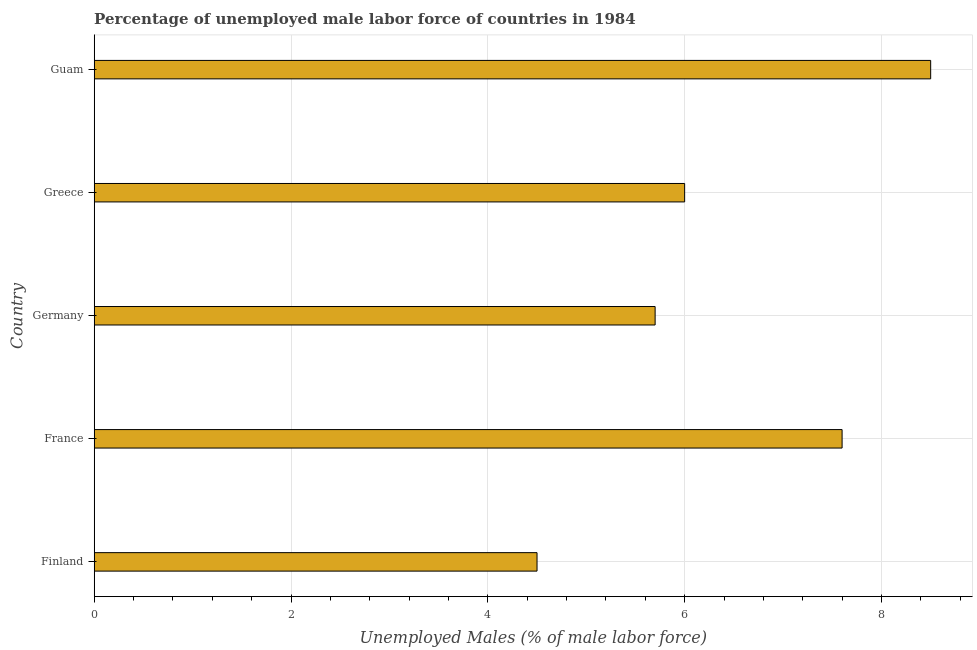Does the graph contain grids?
Ensure brevity in your answer.  Yes. What is the title of the graph?
Offer a very short reply. Percentage of unemployed male labor force of countries in 1984. What is the label or title of the X-axis?
Your answer should be very brief. Unemployed Males (% of male labor force). What is the total unemployed male labour force in Finland?
Your answer should be very brief. 4.5. Across all countries, what is the minimum total unemployed male labour force?
Your answer should be very brief. 4.5. In which country was the total unemployed male labour force maximum?
Ensure brevity in your answer.  Guam. In which country was the total unemployed male labour force minimum?
Give a very brief answer. Finland. What is the sum of the total unemployed male labour force?
Give a very brief answer. 32.3. What is the difference between the total unemployed male labour force in Finland and Greece?
Offer a very short reply. -1.5. What is the average total unemployed male labour force per country?
Keep it short and to the point. 6.46. What is the median total unemployed male labour force?
Make the answer very short. 6. In how many countries, is the total unemployed male labour force greater than 8 %?
Ensure brevity in your answer.  1. What is the ratio of the total unemployed male labour force in Finland to that in Greece?
Provide a short and direct response. 0.75. What is the difference between the highest and the second highest total unemployed male labour force?
Offer a terse response. 0.9. In how many countries, is the total unemployed male labour force greater than the average total unemployed male labour force taken over all countries?
Give a very brief answer. 2. How many bars are there?
Provide a short and direct response. 5. How many countries are there in the graph?
Give a very brief answer. 5. What is the Unemployed Males (% of male labor force) in Finland?
Offer a very short reply. 4.5. What is the Unemployed Males (% of male labor force) of France?
Provide a succinct answer. 7.6. What is the Unemployed Males (% of male labor force) in Germany?
Offer a very short reply. 5.7. What is the Unemployed Males (% of male labor force) of Greece?
Give a very brief answer. 6. What is the difference between the Unemployed Males (% of male labor force) in Finland and Germany?
Provide a succinct answer. -1.2. What is the difference between the Unemployed Males (% of male labor force) in France and Germany?
Offer a terse response. 1.9. What is the difference between the Unemployed Males (% of male labor force) in France and Greece?
Keep it short and to the point. 1.6. What is the difference between the Unemployed Males (% of male labor force) in Germany and Greece?
Keep it short and to the point. -0.3. What is the difference between the Unemployed Males (% of male labor force) in Germany and Guam?
Give a very brief answer. -2.8. What is the ratio of the Unemployed Males (% of male labor force) in Finland to that in France?
Your answer should be very brief. 0.59. What is the ratio of the Unemployed Males (% of male labor force) in Finland to that in Germany?
Keep it short and to the point. 0.79. What is the ratio of the Unemployed Males (% of male labor force) in Finland to that in Guam?
Your answer should be compact. 0.53. What is the ratio of the Unemployed Males (% of male labor force) in France to that in Germany?
Offer a terse response. 1.33. What is the ratio of the Unemployed Males (% of male labor force) in France to that in Greece?
Provide a succinct answer. 1.27. What is the ratio of the Unemployed Males (% of male labor force) in France to that in Guam?
Offer a terse response. 0.89. What is the ratio of the Unemployed Males (% of male labor force) in Germany to that in Guam?
Keep it short and to the point. 0.67. What is the ratio of the Unemployed Males (% of male labor force) in Greece to that in Guam?
Your answer should be compact. 0.71. 